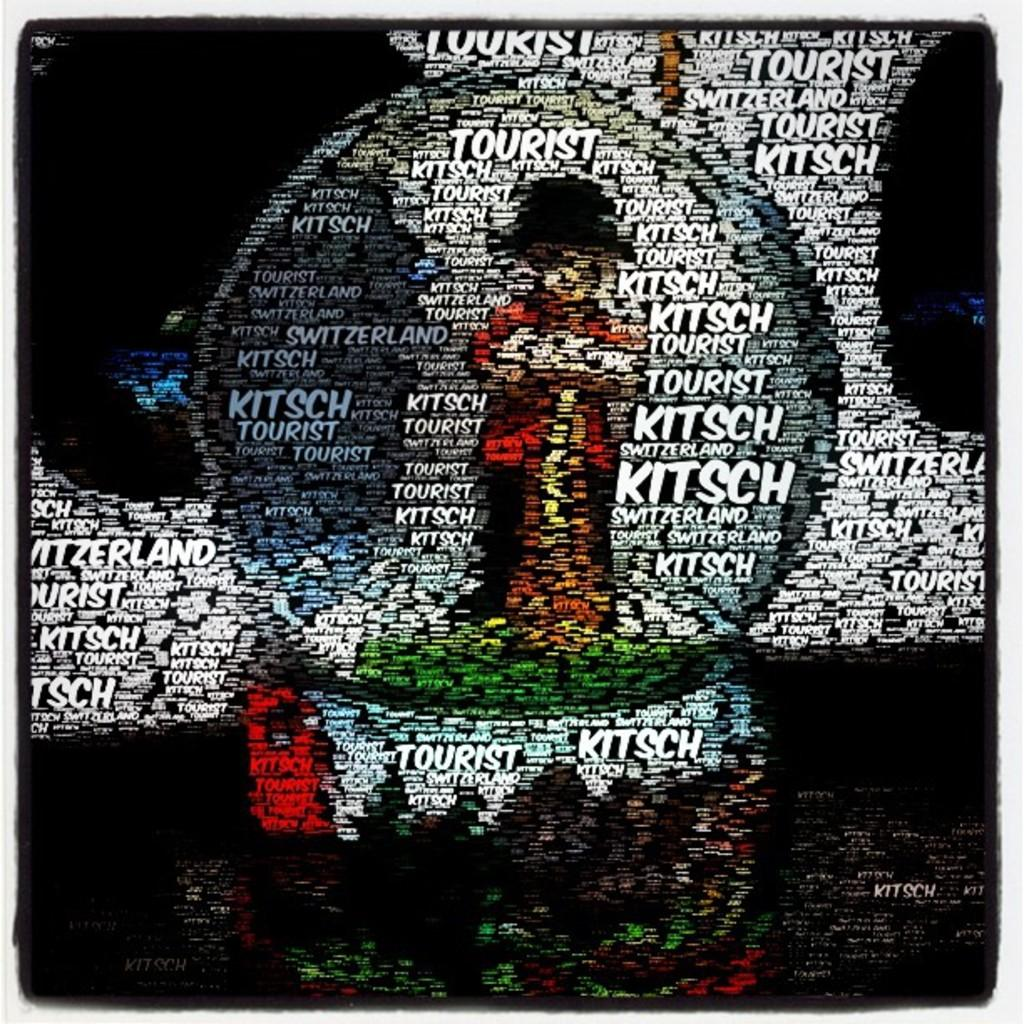<image>
Provide a brief description of the given image. An artwork advertising the piece Tourist by Kitsch. 